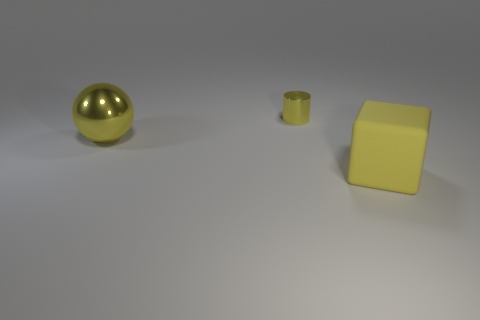Add 2 big cylinders. How many objects exist? 5 Subtract all cylinders. How many objects are left? 2 Subtract 1 yellow cylinders. How many objects are left? 2 Subtract all small cyan metal things. Subtract all tiny shiny cylinders. How many objects are left? 2 Add 2 small yellow shiny objects. How many small yellow shiny objects are left? 3 Add 2 red rubber cubes. How many red rubber cubes exist? 2 